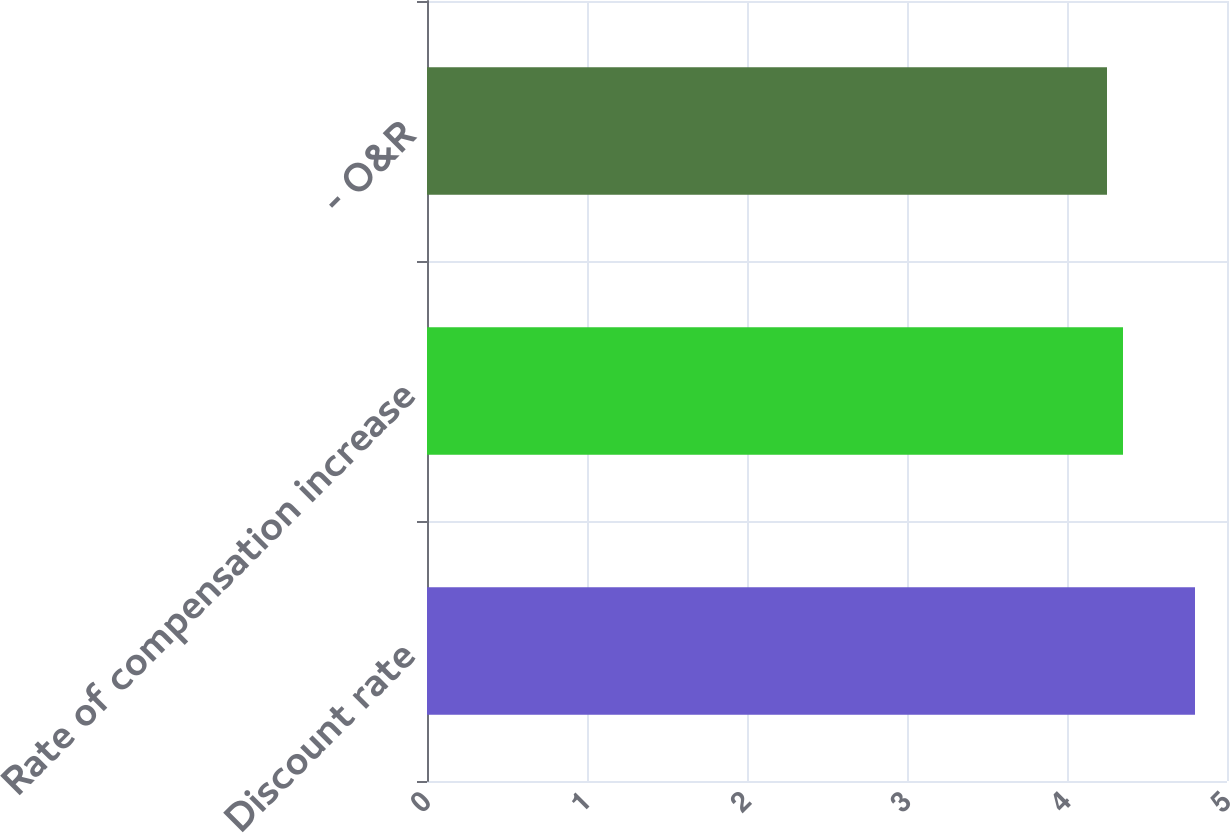Convert chart. <chart><loc_0><loc_0><loc_500><loc_500><bar_chart><fcel>Discount rate<fcel>Rate of compensation increase<fcel>- O&R<nl><fcel>4.8<fcel>4.35<fcel>4.25<nl></chart> 